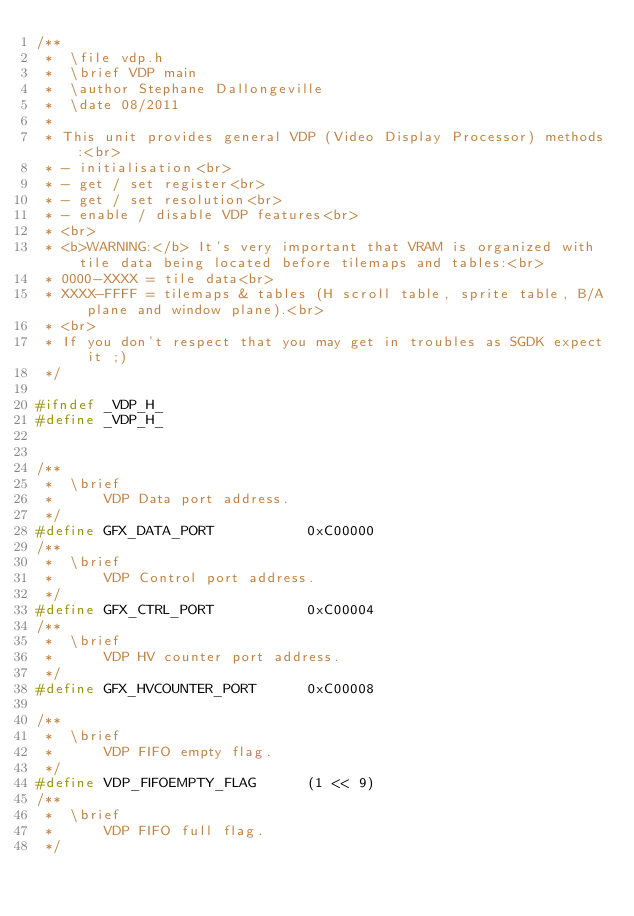Convert code to text. <code><loc_0><loc_0><loc_500><loc_500><_C_>/**
 *  \file vdp.h
 *  \brief VDP main
 *  \author Stephane Dallongeville
 *  \date 08/2011
 *
 * This unit provides general VDP (Video Display Processor) methods:<br>
 * - initialisation<br>
 * - get / set register<br>
 * - get / set resolution<br>
 * - enable / disable VDP features<br>
 * <br>
 * <b>WARNING:</b> It's very important that VRAM is organized with tile data being located before tilemaps and tables:<br>
 * 0000-XXXX = tile data<br>
 * XXXX-FFFF = tilemaps & tables (H scroll table, sprite table, B/A plane and window plane).<br>
 * <br>
 * If you don't respect that you may get in troubles as SGDK expect it ;)
 */

#ifndef _VDP_H_
#define _VDP_H_


/**
 *  \brief
 *      VDP Data port address.
 */
#define GFX_DATA_PORT           0xC00000
/**
 *  \brief
 *      VDP Control port address.
 */
#define GFX_CTRL_PORT           0xC00004
/**
 *  \brief
 *      VDP HV counter port address.
 */
#define GFX_HVCOUNTER_PORT      0xC00008

/**
 *  \brief
 *      VDP FIFO empty flag.
 */
#define VDP_FIFOEMPTY_FLAG      (1 << 9)
/**
 *  \brief
 *      VDP FIFO full flag.
 */</code> 